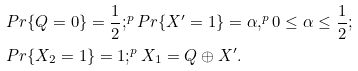<formula> <loc_0><loc_0><loc_500><loc_500>& P r \{ Q = 0 \} = \frac { 1 } { 2 } ; ^ { p } P r \{ X ^ { \prime } = 1 \} = \alpha , ^ { p } 0 \leq \alpha \leq \frac { 1 } { 2 } ; \\ & P r \{ X _ { 2 } = 1 \} = 1 ; ^ { p } X _ { 1 } = Q \oplus X ^ { \prime } .</formula> 